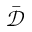Convert formula to latex. <formula><loc_0><loc_0><loc_500><loc_500>\bar { \mathcal { D } }</formula> 